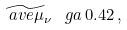<formula> <loc_0><loc_0><loc_500><loc_500>\widetilde { \ a v e { \mu _ { \nu } } } \, \ g a \, 0 . 4 2 \, ,</formula> 